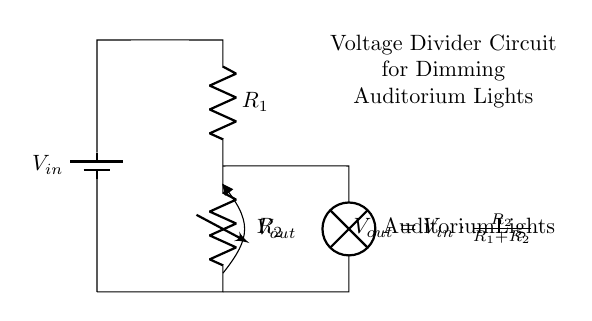What is the input voltage in the circuit? The input voltage, represented as V_in in the diagram, is the voltage provided by the battery which supplies power to the entire circuit.
Answer: V_in What component controls the dimming of the auditorium lights? The component that directly controls the dimming is the variable resistor, labeled as R_2 in the circuit, which can be adjusted to change its resistance and thus adjust the output voltage.
Answer: R_2 What is the purpose of the voltage divider in this circuit? The purpose of the voltage divider created by R_1 and R_2 is to take the input voltage and reduce it to the desired output voltage, V_out, that powers the auditorium lights.
Answer: Dimming If R_1 equals 10 ohms and R_2 equals 30 ohms, what is the output voltage when V_in is 120 volts? To find the output voltage (V_out), we apply the voltage divider formula: V_out = V_in * (R_2 / (R_1 + R_2)). Plugging in the values gives: V_out = 120 * (30 / (10 + 30)) = 90 volts.
Answer: 90 volts What is the relationship between R_1 and R_2 concerning V_out? The relationship can be described by the voltage divider equation, indicating that V_out is proportional to the resistance of R_2 relative to the total resistance of R_1 and R_2. As R_2 increases compared to R_1, V_out increases.
Answer: Proportional What happens to V_out if R_2 is decreased? Decreasing R_2 reduces its share of the total resistance in the circuit, which leads to a lower output voltage V_out, as less voltage is dropped across R_2.
Answer: Decreases 